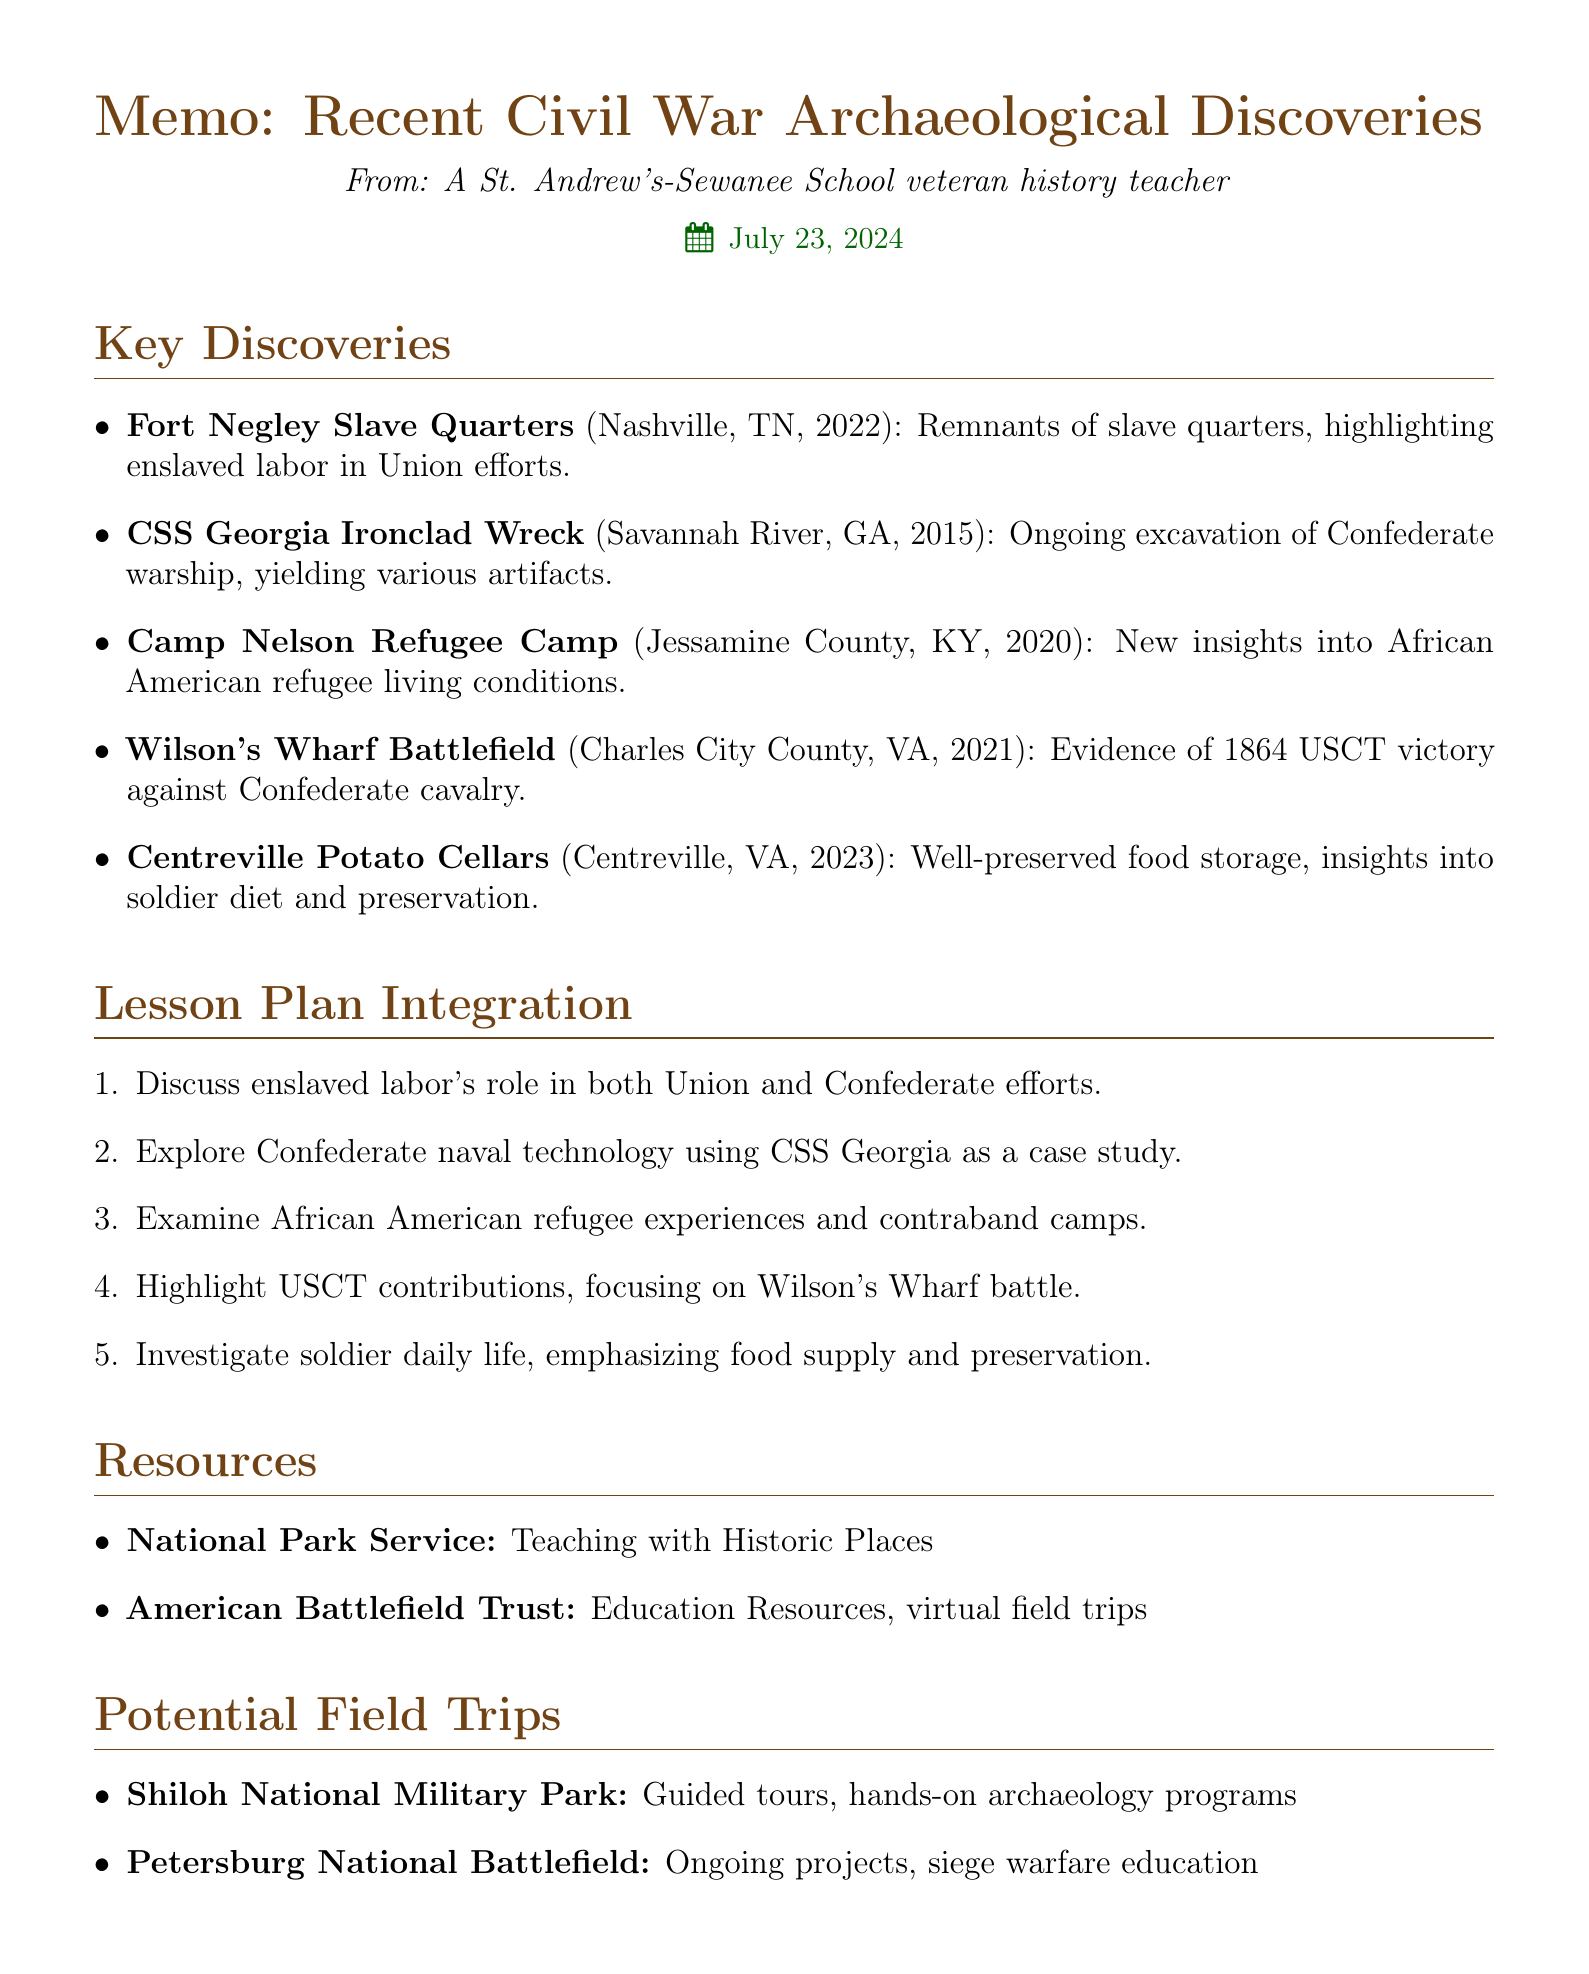What was discovered at Fort Negley? The document states that remnants of slave quarters were uncovered, shedding light on the lives of enslaved African Americans.
Answer: Slave quarters In which year was the CSS Georgia Ironclad Wreck discovered? The document mentions that the CSS Georgia was discovered in 2015.
Answer: 2015 Which location focuses on the living conditions of African American refugees? The document indicates that Camp Nelson revealed information about the living conditions of African American refugees.
Answer: Camp Nelson What does the excavation at Centreville reveal about soldiers? According to the document, the excavation of potato cellars provides insights into soldiers' diet and food preservation techniques.
Answer: Soldier diet Which document section discusses lesson plan integration? The document explicitly has a section titled "Lesson Plan Integration."
Answer: Lesson Plan Integration Who can be contacted about Civil War archaeology at James Madison University? The document lists Dr. Clarence Geier as the contact for Civil War archaeology at James Madison University.
Answer: Dr. Clarence Geier What type of educational resources does the American Battlefield Trust provide? The document describes that the American Battlefield Trust offers education resources and virtual field trips.
Answer: Education resources What is one potential field trip location mentioned? The document lists Shiloh National Military Park as one of the potential field trip locations.
Answer: Shiloh National Military Park 